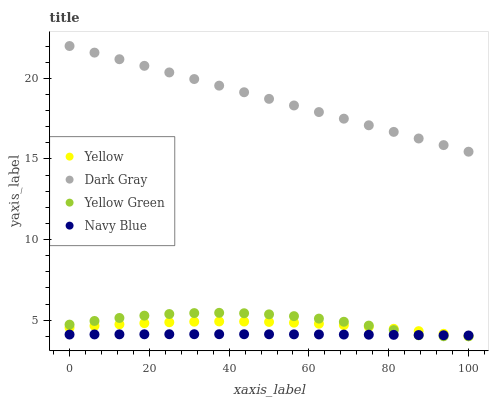Does Navy Blue have the minimum area under the curve?
Answer yes or no. Yes. Does Dark Gray have the maximum area under the curve?
Answer yes or no. Yes. Does Yellow Green have the minimum area under the curve?
Answer yes or no. No. Does Yellow Green have the maximum area under the curve?
Answer yes or no. No. Is Dark Gray the smoothest?
Answer yes or no. Yes. Is Yellow Green the roughest?
Answer yes or no. Yes. Is Navy Blue the smoothest?
Answer yes or no. No. Is Navy Blue the roughest?
Answer yes or no. No. Does Yellow Green have the lowest value?
Answer yes or no. Yes. Does Navy Blue have the lowest value?
Answer yes or no. No. Does Dark Gray have the highest value?
Answer yes or no. Yes. Does Yellow Green have the highest value?
Answer yes or no. No. Is Navy Blue less than Dark Gray?
Answer yes or no. Yes. Is Dark Gray greater than Yellow?
Answer yes or no. Yes. Does Yellow Green intersect Yellow?
Answer yes or no. Yes. Is Yellow Green less than Yellow?
Answer yes or no. No. Is Yellow Green greater than Yellow?
Answer yes or no. No. Does Navy Blue intersect Dark Gray?
Answer yes or no. No. 